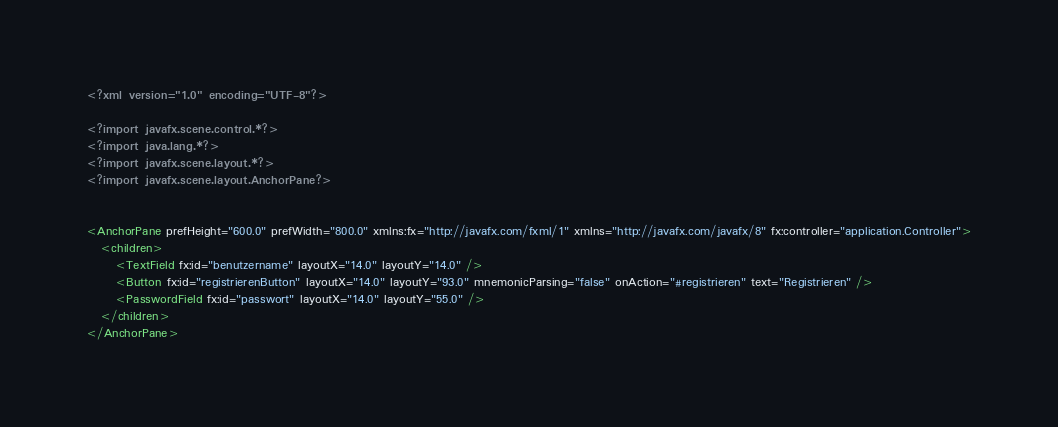Convert code to text. <code><loc_0><loc_0><loc_500><loc_500><_XML_><?xml version="1.0" encoding="UTF-8"?>

<?import javafx.scene.control.*?>
<?import java.lang.*?>
<?import javafx.scene.layout.*?>
<?import javafx.scene.layout.AnchorPane?>


<AnchorPane prefHeight="600.0" prefWidth="800.0" xmlns:fx="http://javafx.com/fxml/1" xmlns="http://javafx.com/javafx/8" fx:controller="application.Controller">
   <children>
      <TextField fx:id="benutzername" layoutX="14.0" layoutY="14.0" />
      <Button fx:id="registrierenButton" layoutX="14.0" layoutY="93.0" mnemonicParsing="false" onAction="#registrieren" text="Registrieren" />
      <PasswordField fx:id="passwort" layoutX="14.0" layoutY="55.0" />
   </children>
</AnchorPane>
</code> 